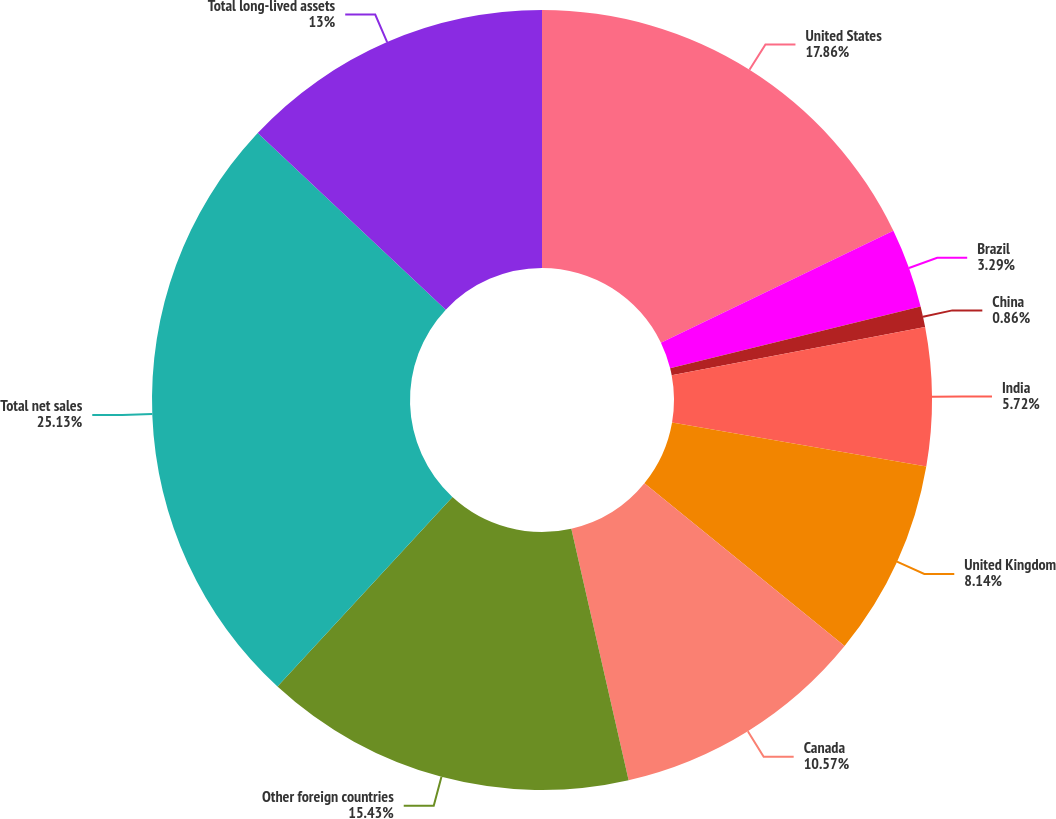Convert chart. <chart><loc_0><loc_0><loc_500><loc_500><pie_chart><fcel>United States<fcel>Brazil<fcel>China<fcel>India<fcel>United Kingdom<fcel>Canada<fcel>Other foreign countries<fcel>Total net sales<fcel>Total long-lived assets<nl><fcel>17.86%<fcel>3.29%<fcel>0.86%<fcel>5.72%<fcel>8.14%<fcel>10.57%<fcel>15.43%<fcel>25.14%<fcel>13.0%<nl></chart> 